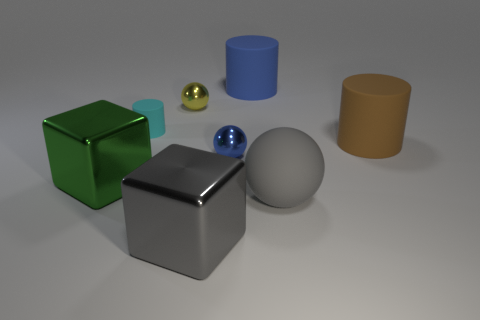Are there fewer big green blocks right of the large brown rubber cylinder than large metallic things in front of the big green cube?
Give a very brief answer. Yes. Do the sphere that is in front of the small blue sphere and the cube that is on the right side of the cyan cylinder have the same color?
Offer a very short reply. Yes. The thing that is in front of the big brown object and on the right side of the blue matte thing is made of what material?
Give a very brief answer. Rubber. Are there any tiny spheres?
Ensure brevity in your answer.  Yes. There is a big gray object that is the same material as the small yellow object; what shape is it?
Offer a terse response. Cube. Do the blue rubber thing and the rubber thing that is to the left of the big blue thing have the same shape?
Offer a terse response. Yes. What material is the tiny ball to the right of the small metal thing behind the brown thing made of?
Offer a very short reply. Metal. What number of other objects are there of the same shape as the yellow metal object?
Provide a short and direct response. 2. There is a small shiny thing that is left of the blue shiny ball; is it the same shape as the small metallic object in front of the yellow sphere?
Your answer should be compact. Yes. What is the green cube made of?
Provide a short and direct response. Metal. 